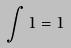<formula> <loc_0><loc_0><loc_500><loc_500>\int 1 = 1</formula> 